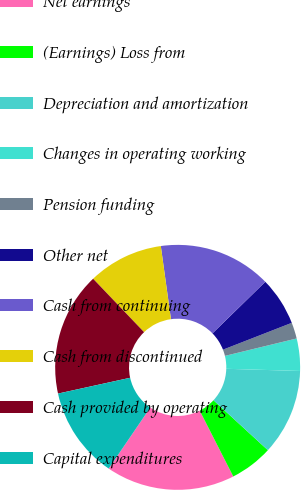Convert chart to OTSL. <chart><loc_0><loc_0><loc_500><loc_500><pie_chart><fcel>Net earnings<fcel>(Earnings) Loss from<fcel>Depreciation and amortization<fcel>Changes in operating working<fcel>Pension funding<fcel>Other net<fcel>Cash from continuing<fcel>Cash from discontinued<fcel>Cash provided by operating<fcel>Capital expenditures<nl><fcel>17.02%<fcel>5.68%<fcel>11.35%<fcel>4.26%<fcel>2.13%<fcel>6.39%<fcel>14.89%<fcel>9.93%<fcel>16.31%<fcel>12.05%<nl></chart> 